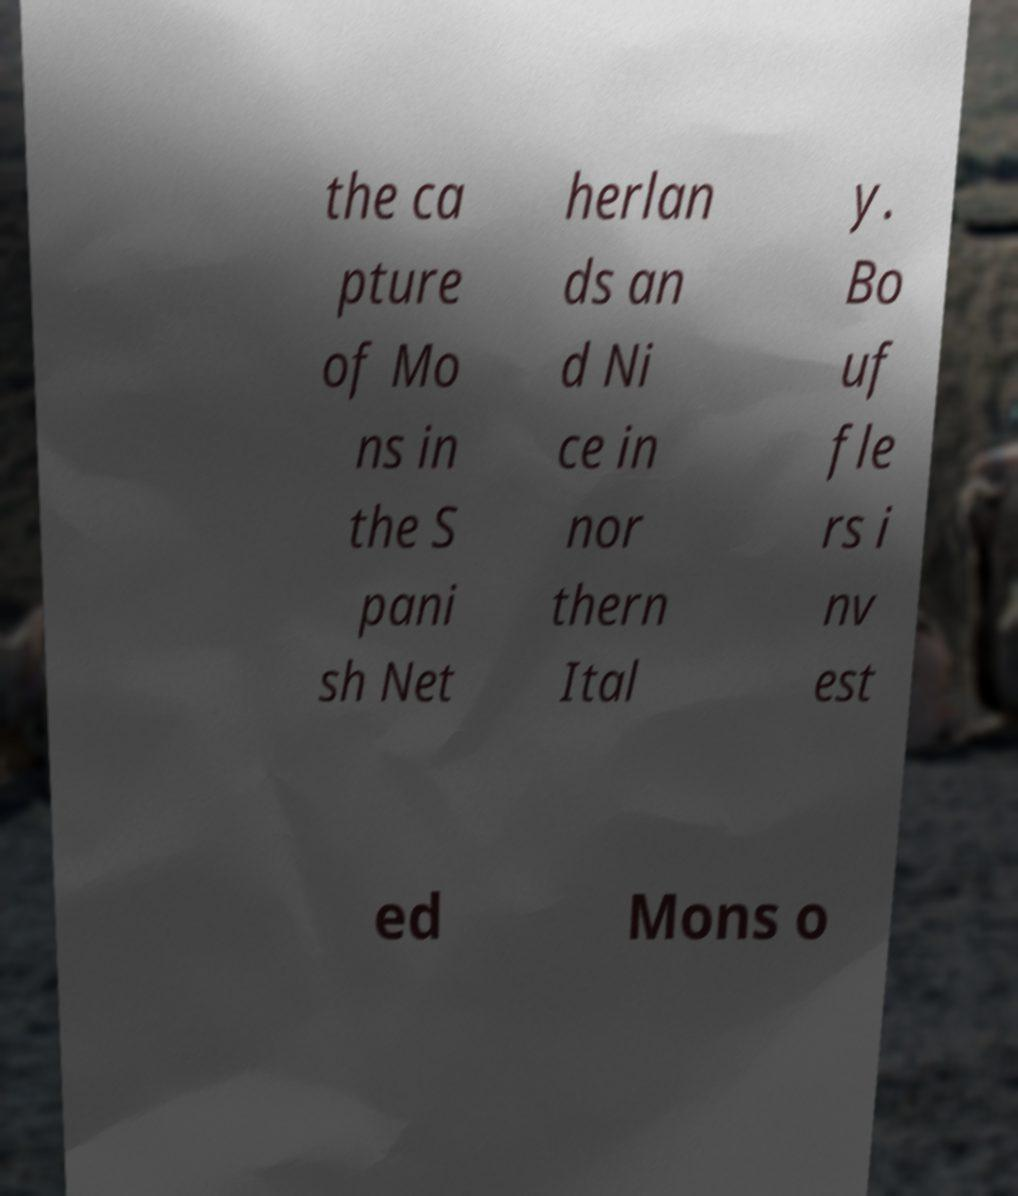What messages or text are displayed in this image? I need them in a readable, typed format. the ca pture of Mo ns in the S pani sh Net herlan ds an d Ni ce in nor thern Ital y. Bo uf fle rs i nv est ed Mons o 